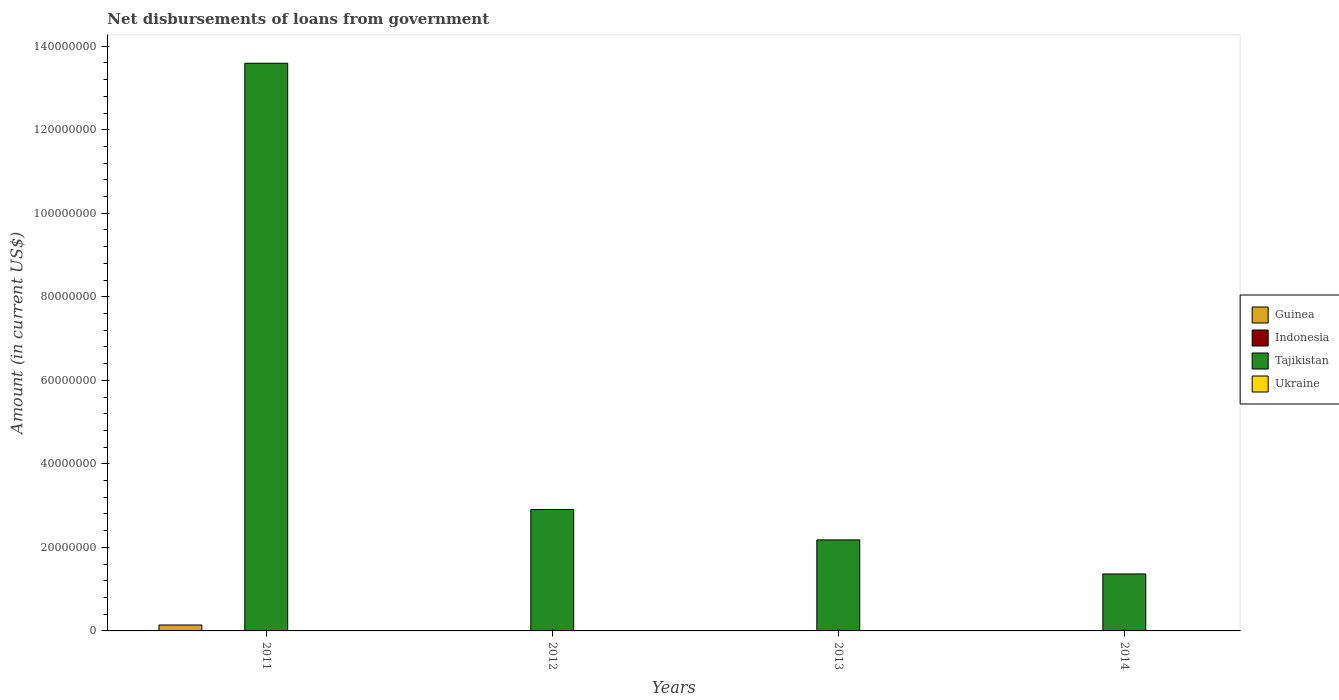How many different coloured bars are there?
Your response must be concise. 2. Are the number of bars on each tick of the X-axis equal?
Provide a short and direct response. No. How many bars are there on the 1st tick from the left?
Offer a very short reply. 2. How many bars are there on the 1st tick from the right?
Provide a short and direct response. 1. Across all years, what is the maximum amount of loan disbursed from government in Guinea?
Ensure brevity in your answer.  1.42e+06. Across all years, what is the minimum amount of loan disbursed from government in Guinea?
Offer a terse response. 0. What is the total amount of loan disbursed from government in Ukraine in the graph?
Make the answer very short. 0. What is the difference between the amount of loan disbursed from government in Tajikistan in 2013 and that in 2014?
Your response must be concise. 8.15e+06. What is the difference between the amount of loan disbursed from government in Tajikistan in 2011 and the amount of loan disbursed from government in Guinea in 2013?
Ensure brevity in your answer.  1.36e+08. What is the average amount of loan disbursed from government in Tajikistan per year?
Provide a short and direct response. 5.01e+07. In how many years, is the amount of loan disbursed from government in Tajikistan greater than 48000000 US$?
Provide a succinct answer. 1. What is the ratio of the amount of loan disbursed from government in Tajikistan in 2012 to that in 2013?
Provide a succinct answer. 1.33. What is the difference between the highest and the second highest amount of loan disbursed from government in Tajikistan?
Your response must be concise. 1.07e+08. What is the difference between the highest and the lowest amount of loan disbursed from government in Tajikistan?
Offer a terse response. 1.22e+08. In how many years, is the amount of loan disbursed from government in Tajikistan greater than the average amount of loan disbursed from government in Tajikistan taken over all years?
Provide a short and direct response. 1. Is it the case that in every year, the sum of the amount of loan disbursed from government in Indonesia and amount of loan disbursed from government in Ukraine is greater than the sum of amount of loan disbursed from government in Tajikistan and amount of loan disbursed from government in Guinea?
Give a very brief answer. No. How many bars are there?
Offer a terse response. 5. What is the difference between two consecutive major ticks on the Y-axis?
Your answer should be very brief. 2.00e+07. Does the graph contain any zero values?
Provide a short and direct response. Yes. How are the legend labels stacked?
Your answer should be compact. Vertical. What is the title of the graph?
Provide a short and direct response. Net disbursements of loans from government. Does "Gabon" appear as one of the legend labels in the graph?
Provide a succinct answer. No. What is the label or title of the X-axis?
Ensure brevity in your answer.  Years. What is the Amount (in current US$) of Guinea in 2011?
Your answer should be very brief. 1.42e+06. What is the Amount (in current US$) in Tajikistan in 2011?
Keep it short and to the point. 1.36e+08. What is the Amount (in current US$) in Ukraine in 2011?
Your response must be concise. 0. What is the Amount (in current US$) of Tajikistan in 2012?
Ensure brevity in your answer.  2.91e+07. What is the Amount (in current US$) in Tajikistan in 2013?
Provide a succinct answer. 2.18e+07. What is the Amount (in current US$) in Ukraine in 2013?
Your answer should be compact. 0. What is the Amount (in current US$) of Tajikistan in 2014?
Provide a succinct answer. 1.36e+07. What is the Amount (in current US$) in Ukraine in 2014?
Your answer should be very brief. 0. Across all years, what is the maximum Amount (in current US$) in Guinea?
Offer a terse response. 1.42e+06. Across all years, what is the maximum Amount (in current US$) of Tajikistan?
Offer a terse response. 1.36e+08. Across all years, what is the minimum Amount (in current US$) in Guinea?
Ensure brevity in your answer.  0. Across all years, what is the minimum Amount (in current US$) in Tajikistan?
Offer a very short reply. 1.36e+07. What is the total Amount (in current US$) of Guinea in the graph?
Your response must be concise. 1.42e+06. What is the total Amount (in current US$) in Indonesia in the graph?
Keep it short and to the point. 0. What is the total Amount (in current US$) of Tajikistan in the graph?
Your answer should be compact. 2.00e+08. What is the difference between the Amount (in current US$) of Tajikistan in 2011 and that in 2012?
Your response must be concise. 1.07e+08. What is the difference between the Amount (in current US$) of Tajikistan in 2011 and that in 2013?
Ensure brevity in your answer.  1.14e+08. What is the difference between the Amount (in current US$) of Tajikistan in 2011 and that in 2014?
Make the answer very short. 1.22e+08. What is the difference between the Amount (in current US$) in Tajikistan in 2012 and that in 2013?
Your response must be concise. 7.28e+06. What is the difference between the Amount (in current US$) of Tajikistan in 2012 and that in 2014?
Provide a succinct answer. 1.54e+07. What is the difference between the Amount (in current US$) of Tajikistan in 2013 and that in 2014?
Provide a succinct answer. 8.15e+06. What is the difference between the Amount (in current US$) in Guinea in 2011 and the Amount (in current US$) in Tajikistan in 2012?
Your answer should be compact. -2.77e+07. What is the difference between the Amount (in current US$) of Guinea in 2011 and the Amount (in current US$) of Tajikistan in 2013?
Offer a terse response. -2.04e+07. What is the difference between the Amount (in current US$) of Guinea in 2011 and the Amount (in current US$) of Tajikistan in 2014?
Ensure brevity in your answer.  -1.22e+07. What is the average Amount (in current US$) in Guinea per year?
Your response must be concise. 3.54e+05. What is the average Amount (in current US$) in Tajikistan per year?
Ensure brevity in your answer.  5.01e+07. What is the average Amount (in current US$) of Ukraine per year?
Make the answer very short. 0. In the year 2011, what is the difference between the Amount (in current US$) of Guinea and Amount (in current US$) of Tajikistan?
Your response must be concise. -1.34e+08. What is the ratio of the Amount (in current US$) of Tajikistan in 2011 to that in 2012?
Offer a very short reply. 4.68. What is the ratio of the Amount (in current US$) of Tajikistan in 2011 to that in 2013?
Make the answer very short. 6.24. What is the ratio of the Amount (in current US$) in Tajikistan in 2011 to that in 2014?
Offer a very short reply. 9.96. What is the ratio of the Amount (in current US$) of Tajikistan in 2012 to that in 2013?
Give a very brief answer. 1.33. What is the ratio of the Amount (in current US$) in Tajikistan in 2012 to that in 2014?
Offer a terse response. 2.13. What is the ratio of the Amount (in current US$) in Tajikistan in 2013 to that in 2014?
Provide a succinct answer. 1.6. What is the difference between the highest and the second highest Amount (in current US$) of Tajikistan?
Your answer should be compact. 1.07e+08. What is the difference between the highest and the lowest Amount (in current US$) of Guinea?
Give a very brief answer. 1.42e+06. What is the difference between the highest and the lowest Amount (in current US$) in Tajikistan?
Provide a succinct answer. 1.22e+08. 